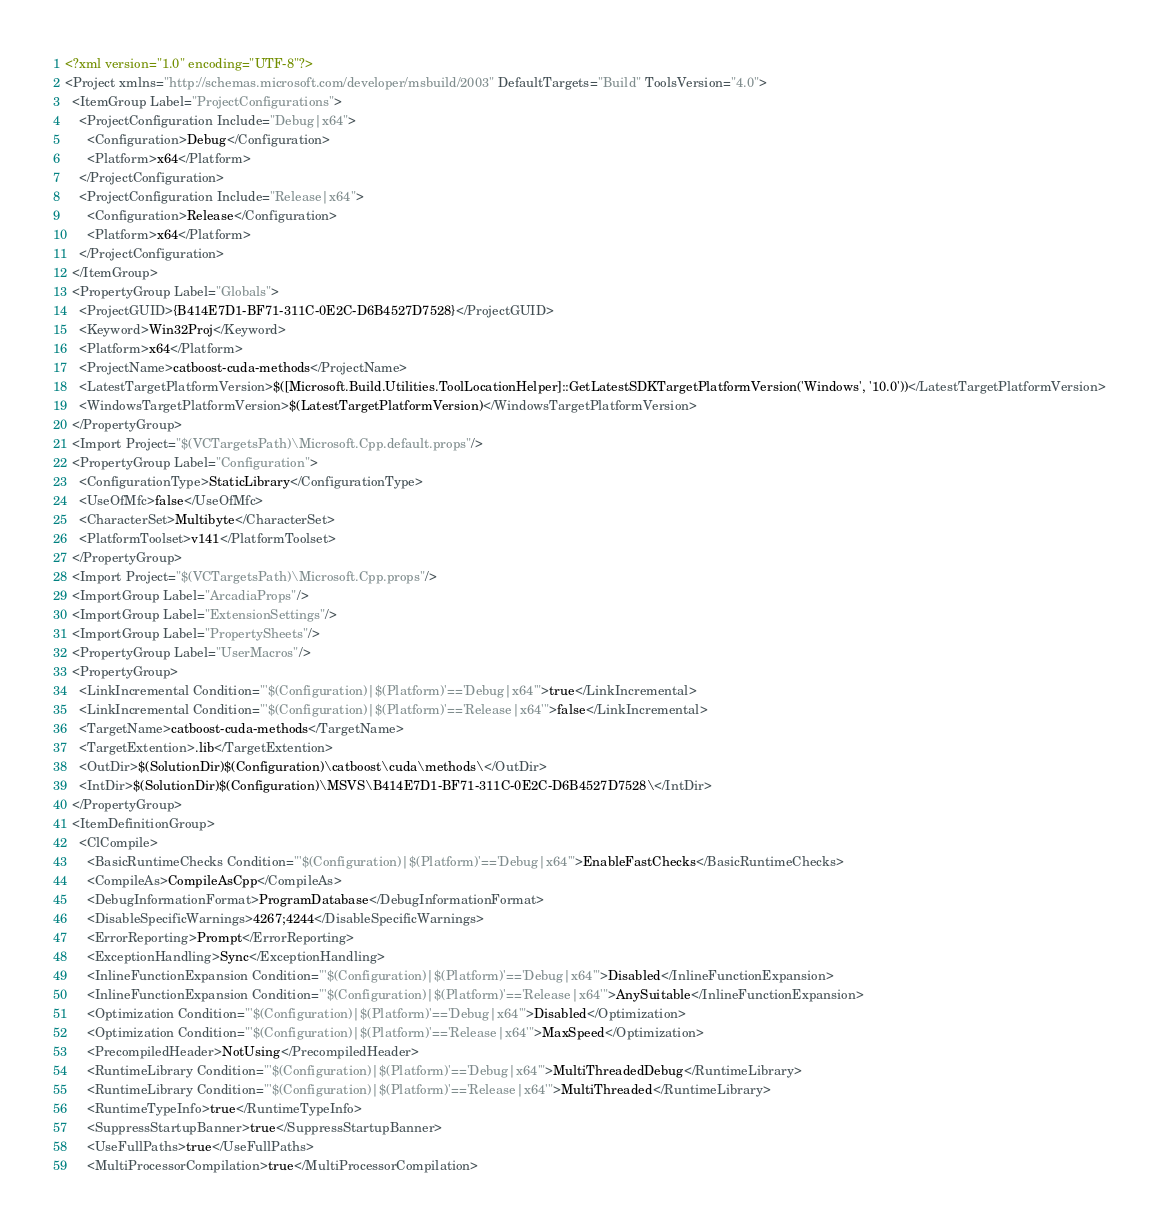<code> <loc_0><loc_0><loc_500><loc_500><_XML_><?xml version="1.0" encoding="UTF-8"?>
<Project xmlns="http://schemas.microsoft.com/developer/msbuild/2003" DefaultTargets="Build" ToolsVersion="4.0">
  <ItemGroup Label="ProjectConfigurations">
    <ProjectConfiguration Include="Debug|x64">
      <Configuration>Debug</Configuration>
      <Platform>x64</Platform>
    </ProjectConfiguration>
    <ProjectConfiguration Include="Release|x64">
      <Configuration>Release</Configuration>
      <Platform>x64</Platform>
    </ProjectConfiguration>
  </ItemGroup>
  <PropertyGroup Label="Globals">
    <ProjectGUID>{B414E7D1-BF71-311C-0E2C-D6B4527D7528}</ProjectGUID>
    <Keyword>Win32Proj</Keyword>
    <Platform>x64</Platform>
    <ProjectName>catboost-cuda-methods</ProjectName>
    <LatestTargetPlatformVersion>$([Microsoft.Build.Utilities.ToolLocationHelper]::GetLatestSDKTargetPlatformVersion('Windows', '10.0'))</LatestTargetPlatformVersion>
    <WindowsTargetPlatformVersion>$(LatestTargetPlatformVersion)</WindowsTargetPlatformVersion>
  </PropertyGroup>
  <Import Project="$(VCTargetsPath)\Microsoft.Cpp.default.props"/>
  <PropertyGroup Label="Configuration">
    <ConfigurationType>StaticLibrary</ConfigurationType>
    <UseOfMfc>false</UseOfMfc>
    <CharacterSet>Multibyte</CharacterSet>
    <PlatformToolset>v141</PlatformToolset>
  </PropertyGroup>
  <Import Project="$(VCTargetsPath)\Microsoft.Cpp.props"/>
  <ImportGroup Label="ArcadiaProps"/>
  <ImportGroup Label="ExtensionSettings"/>
  <ImportGroup Label="PropertySheets"/>
  <PropertyGroup Label="UserMacros"/>
  <PropertyGroup>
    <LinkIncremental Condition="'$(Configuration)|$(Platform)'=='Debug|x64'">true</LinkIncremental>
    <LinkIncremental Condition="'$(Configuration)|$(Platform)'=='Release|x64'">false</LinkIncremental>
    <TargetName>catboost-cuda-methods</TargetName>
    <TargetExtention>.lib</TargetExtention>
    <OutDir>$(SolutionDir)$(Configuration)\catboost\cuda\methods\</OutDir>
    <IntDir>$(SolutionDir)$(Configuration)\MSVS\B414E7D1-BF71-311C-0E2C-D6B4527D7528\</IntDir>
  </PropertyGroup>
  <ItemDefinitionGroup>
    <ClCompile>
      <BasicRuntimeChecks Condition="'$(Configuration)|$(Platform)'=='Debug|x64'">EnableFastChecks</BasicRuntimeChecks>
      <CompileAs>CompileAsCpp</CompileAs>
      <DebugInformationFormat>ProgramDatabase</DebugInformationFormat>
      <DisableSpecificWarnings>4267;4244</DisableSpecificWarnings>
      <ErrorReporting>Prompt</ErrorReporting>
      <ExceptionHandling>Sync</ExceptionHandling>
      <InlineFunctionExpansion Condition="'$(Configuration)|$(Platform)'=='Debug|x64'">Disabled</InlineFunctionExpansion>
      <InlineFunctionExpansion Condition="'$(Configuration)|$(Platform)'=='Release|x64'">AnySuitable</InlineFunctionExpansion>
      <Optimization Condition="'$(Configuration)|$(Platform)'=='Debug|x64'">Disabled</Optimization>
      <Optimization Condition="'$(Configuration)|$(Platform)'=='Release|x64'">MaxSpeed</Optimization>
      <PrecompiledHeader>NotUsing</PrecompiledHeader>
      <RuntimeLibrary Condition="'$(Configuration)|$(Platform)'=='Debug|x64'">MultiThreadedDebug</RuntimeLibrary>
      <RuntimeLibrary Condition="'$(Configuration)|$(Platform)'=='Release|x64'">MultiThreaded</RuntimeLibrary>
      <RuntimeTypeInfo>true</RuntimeTypeInfo>
      <SuppressStartupBanner>true</SuppressStartupBanner>
      <UseFullPaths>true</UseFullPaths>
      <MultiProcessorCompilation>true</MultiProcessorCompilation></code> 